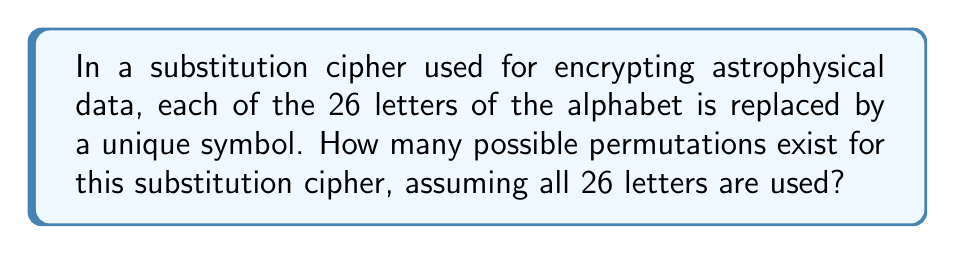Provide a solution to this math problem. To solve this problem, we'll follow these steps:

1. Understand the concept:
   A substitution cipher replaces each letter with a unique symbol. This means we're dealing with a permutation of 26 elements.

2. Recall the formula:
   The number of permutations of n distinct objects is given by n!

3. Apply the formula:
   In this case, n = 26 (for 26 letters of the alphabet)
   Number of permutations = 26!

4. Calculate the result:
   $$26! = 26 \times 25 \times 24 \times ... \times 3 \times 2 \times 1$$
   
   This is a very large number. We can use scientific notation to express it:
   
   $$26! \approx 4.0329 \times 10^{26}$$

5. Interpret the result:
   This enormous number represents the total possible ways to arrange 26 unique symbols to substitute for the 26 letters of the alphabet. Each of these arrangements would create a different substitution cipher, making it extremely challenging for an unauthorized party to decrypt the astrophysical data without knowing the specific arrangement used.
Answer: $26! \approx 4.0329 \times 10^{26}$ 